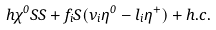<formula> <loc_0><loc_0><loc_500><loc_500>h \chi ^ { 0 } S S + f _ { i } S ( \nu _ { i } \eta ^ { 0 } - l _ { i } \eta ^ { + } ) + h . c .</formula> 